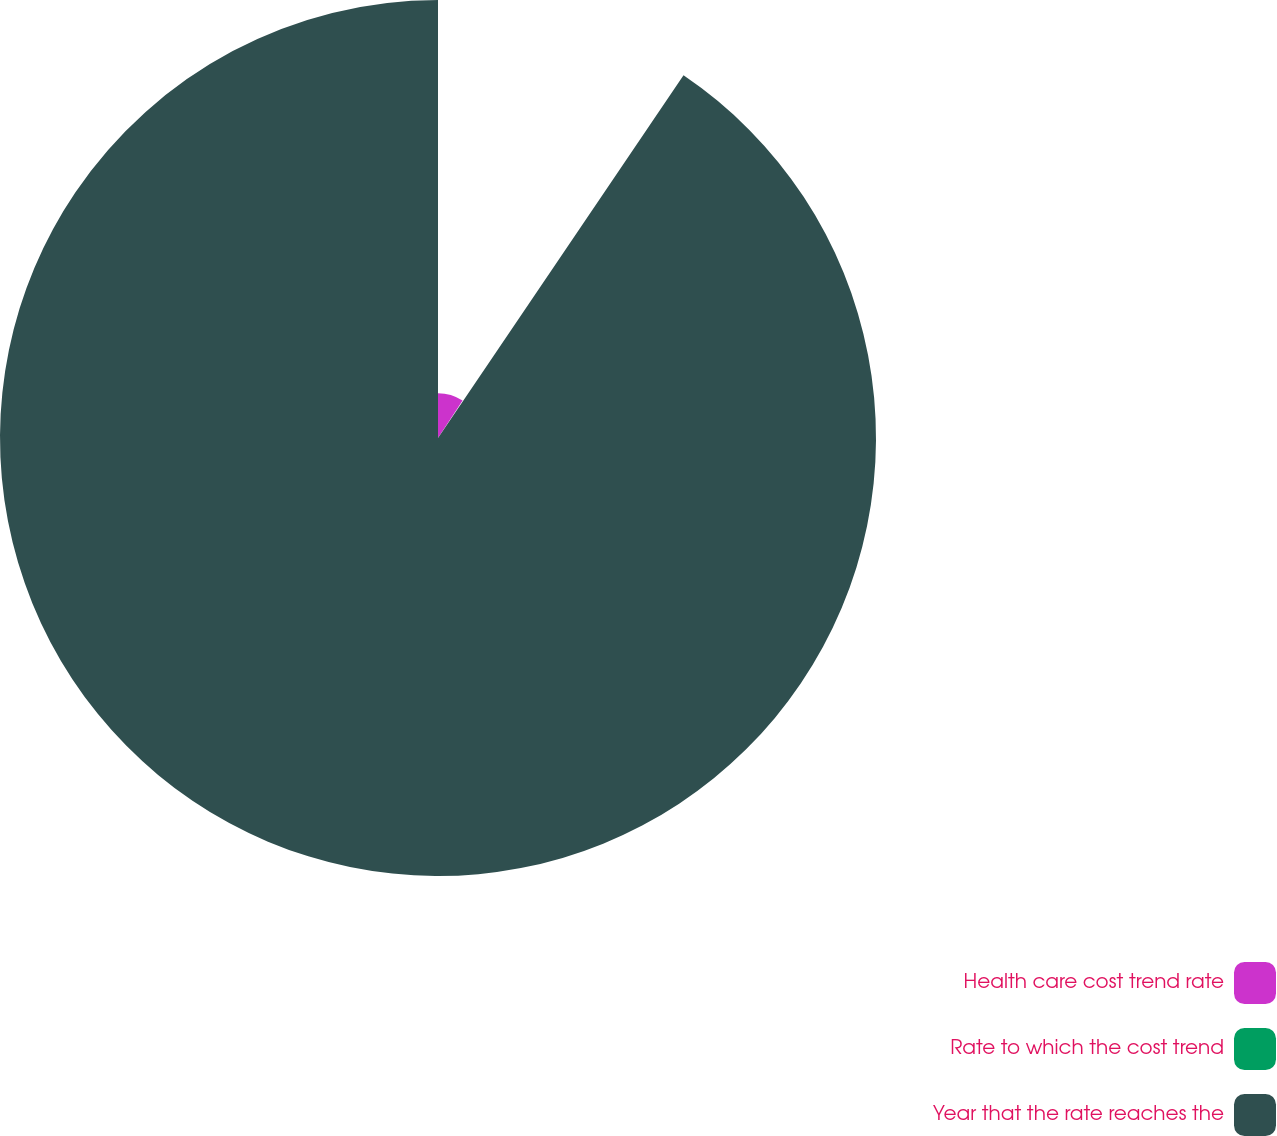Convert chart. <chart><loc_0><loc_0><loc_500><loc_500><pie_chart><fcel>Health care cost trend rate<fcel>Rate to which the cost trend<fcel>Year that the rate reaches the<nl><fcel>9.25%<fcel>0.22%<fcel>90.52%<nl></chart> 